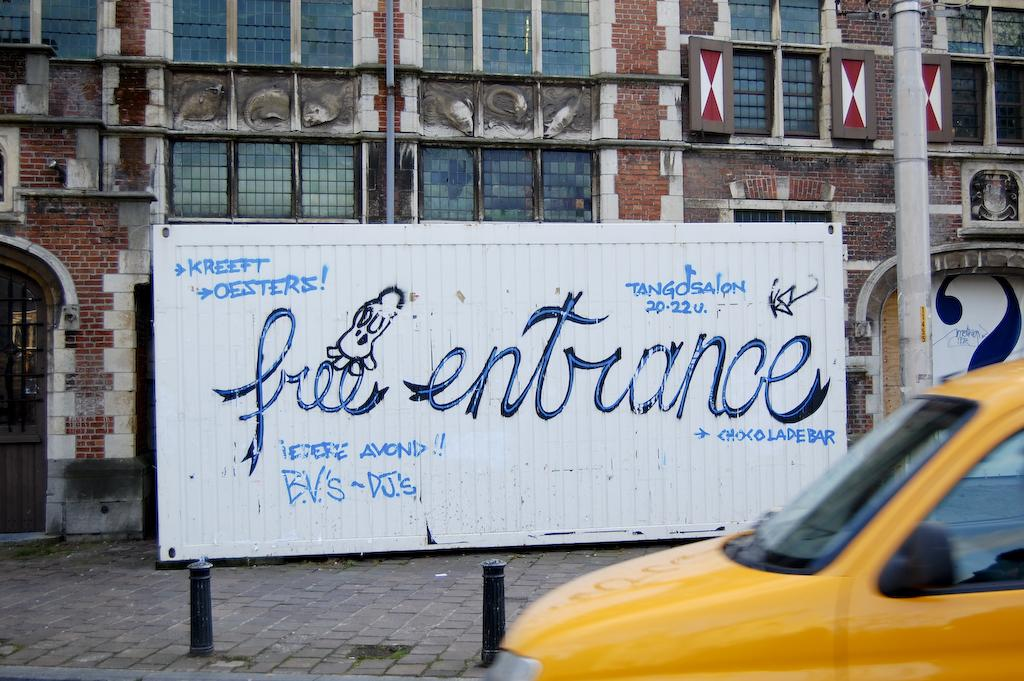Provide a one-sentence caption for the provided image. a sign that says free entrance on it. 